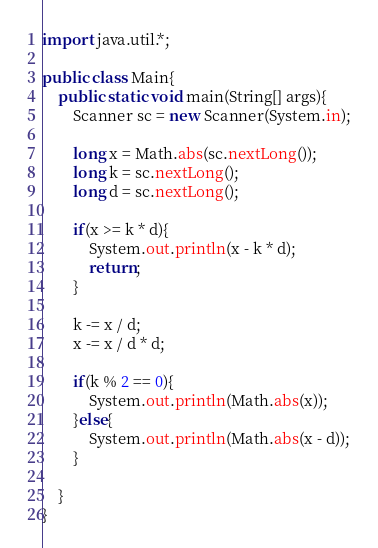<code> <loc_0><loc_0><loc_500><loc_500><_Java_>import java.util.*;

public class Main{
    public static void main(String[] args){
        Scanner sc = new Scanner(System.in);

        long x = Math.abs(sc.nextLong());
        long k = sc.nextLong();
        long d = sc.nextLong();

        if(x >= k * d){
            System.out.println(x - k * d);
            return;
        }

        k -= x / d;
        x -= x / d * d;

        if(k % 2 == 0){
            System.out.println(Math.abs(x));
        }else{
            System.out.println(Math.abs(x - d));
        }

    }
}
</code> 